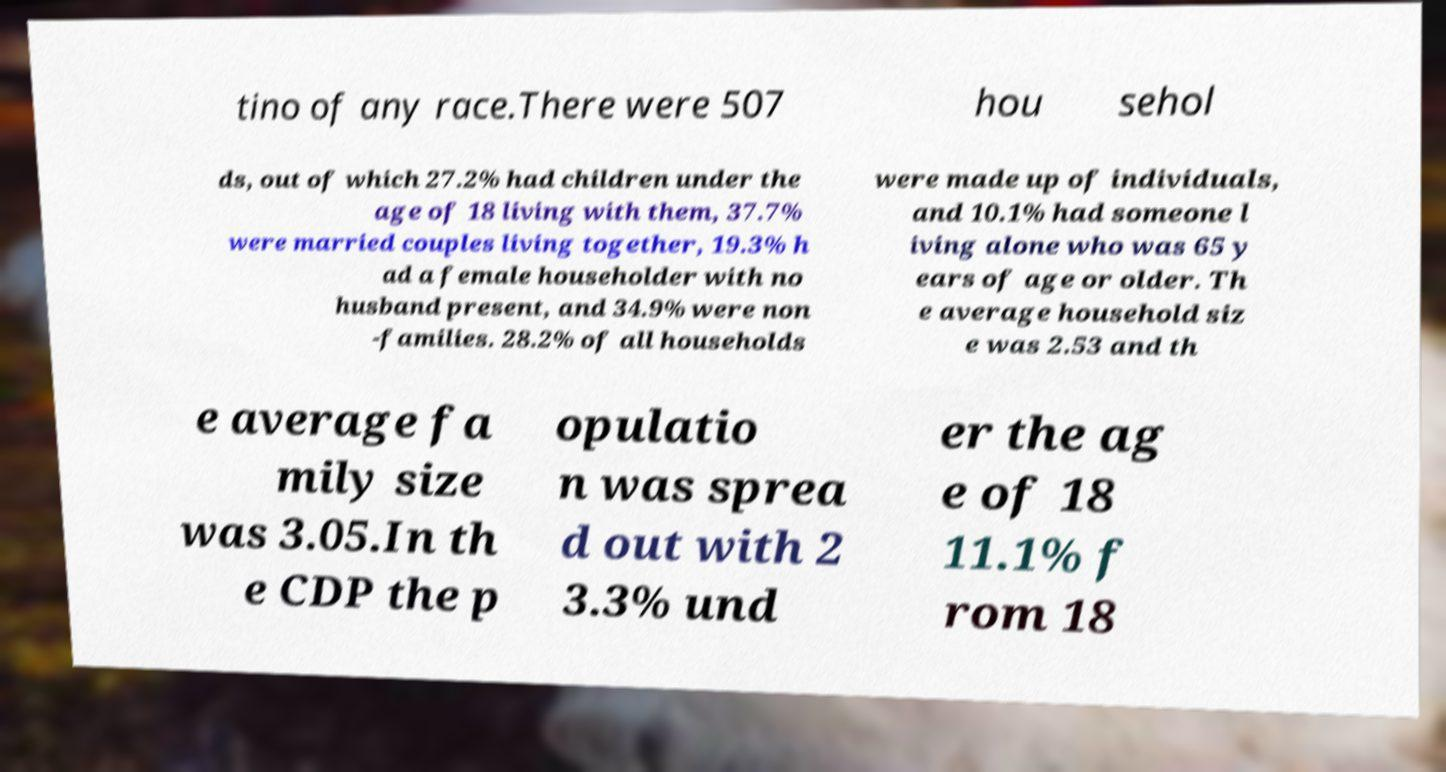Please identify and transcribe the text found in this image. tino of any race.There were 507 hou sehol ds, out of which 27.2% had children under the age of 18 living with them, 37.7% were married couples living together, 19.3% h ad a female householder with no husband present, and 34.9% were non -families. 28.2% of all households were made up of individuals, and 10.1% had someone l iving alone who was 65 y ears of age or older. Th e average household siz e was 2.53 and th e average fa mily size was 3.05.In th e CDP the p opulatio n was sprea d out with 2 3.3% und er the ag e of 18 11.1% f rom 18 